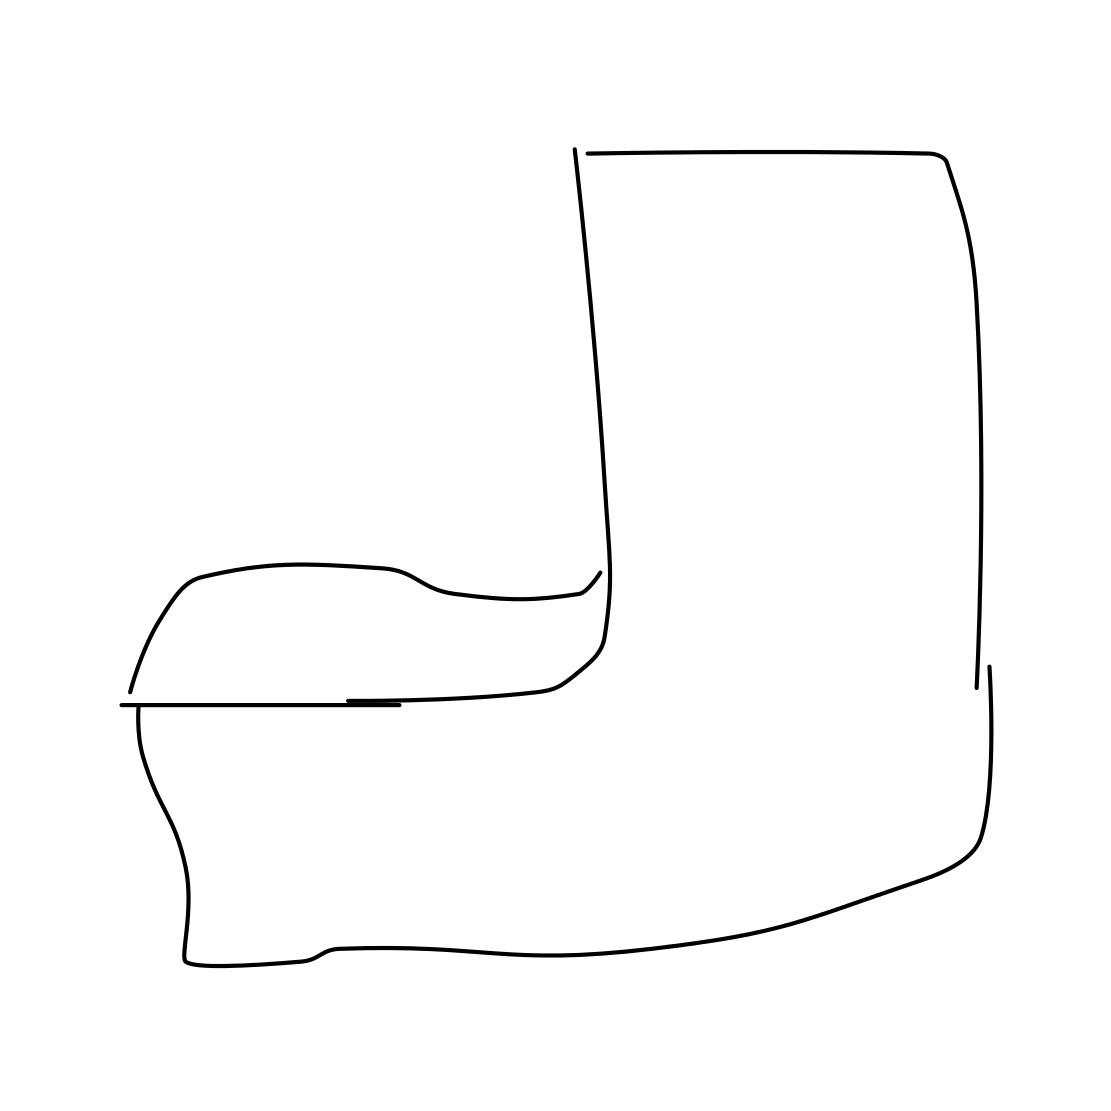Is there a sketchy armchair in the picture? Yes, the image depicts a simple line drawing of an armchair with a sketch-like quality. Its contours suggest the basic shape and structure, exuding a minimalist and abstract aesthetic. 